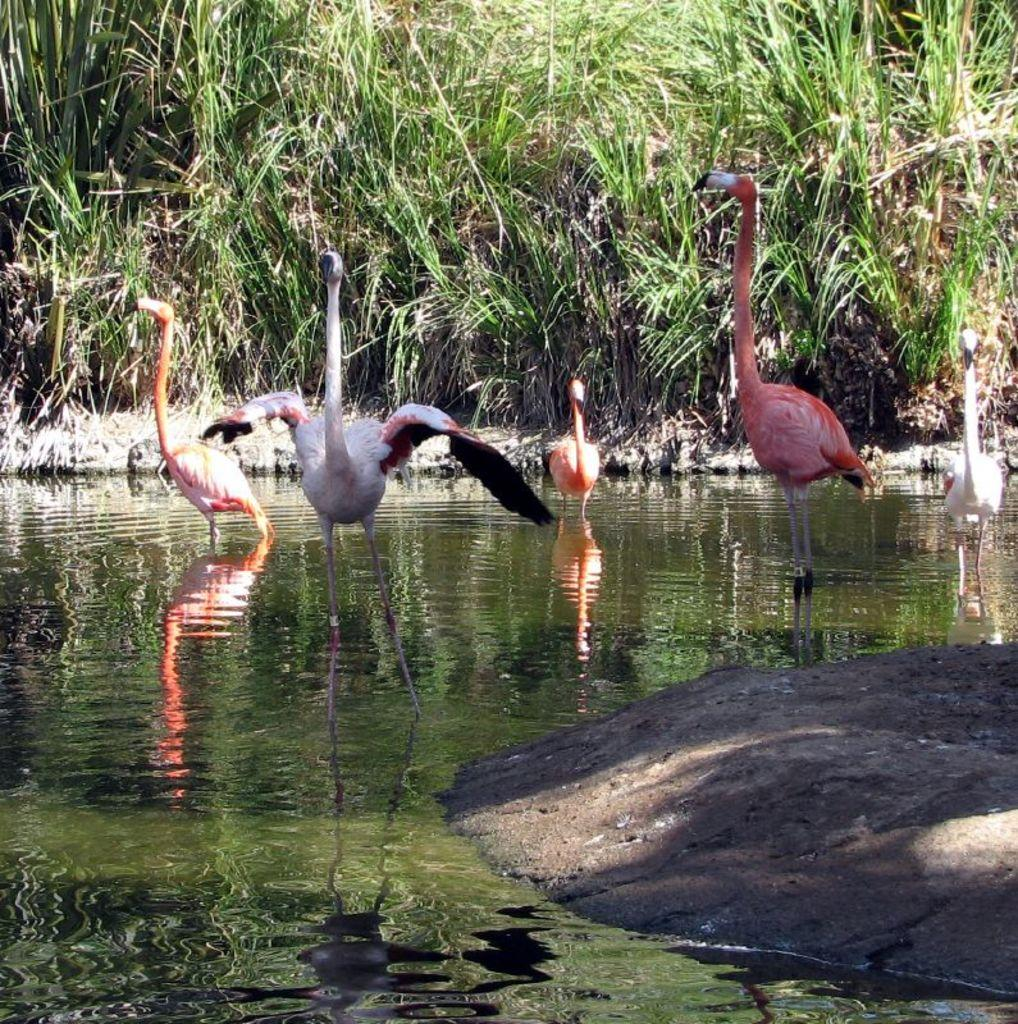What type of animals are in the image? There are flamingos in the image. Where are the flamingos located? The flamingos are standing in the water. What can be seen in the background of the image? There are plants visible in the background. What part of the ground is visible in the image? The ground is visible in the bottom right corner of the image. Can you see a volleyball being played in the image? There is no volleyball or any indication of a game being played in the image. 